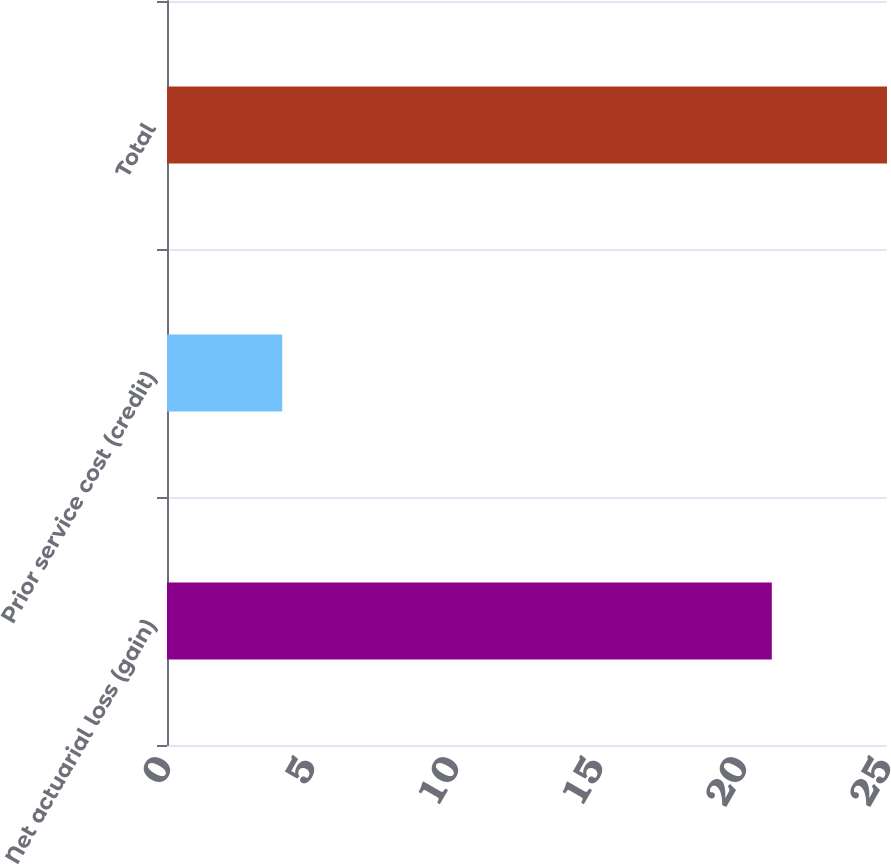Convert chart to OTSL. <chart><loc_0><loc_0><loc_500><loc_500><bar_chart><fcel>Net actuarial loss (gain)<fcel>Prior service cost (credit)<fcel>Total<nl><fcel>21<fcel>4<fcel>25<nl></chart> 